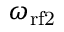<formula> <loc_0><loc_0><loc_500><loc_500>\omega _ { { r f } 2 }</formula> 